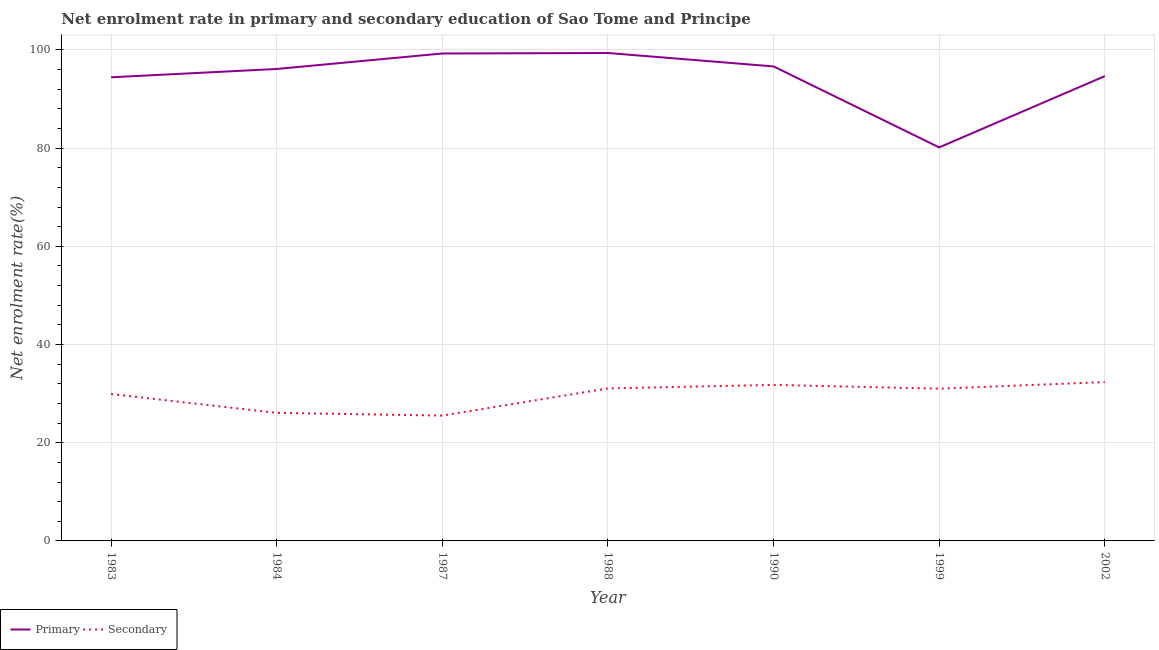What is the enrollment rate in primary education in 1987?
Keep it short and to the point. 99.28. Across all years, what is the maximum enrollment rate in primary education?
Provide a short and direct response. 99.38. Across all years, what is the minimum enrollment rate in primary education?
Your answer should be very brief. 80.15. In which year was the enrollment rate in secondary education maximum?
Ensure brevity in your answer.  2002. In which year was the enrollment rate in secondary education minimum?
Keep it short and to the point. 1987. What is the total enrollment rate in secondary education in the graph?
Make the answer very short. 207.74. What is the difference between the enrollment rate in primary education in 1983 and that in 1990?
Make the answer very short. -2.21. What is the difference between the enrollment rate in primary education in 2002 and the enrollment rate in secondary education in 1988?
Your answer should be very brief. 63.61. What is the average enrollment rate in primary education per year?
Ensure brevity in your answer.  94.38. In the year 2002, what is the difference between the enrollment rate in secondary education and enrollment rate in primary education?
Your answer should be very brief. -62.31. In how many years, is the enrollment rate in primary education greater than 64 %?
Offer a terse response. 7. What is the ratio of the enrollment rate in primary education in 1987 to that in 1988?
Offer a terse response. 1. Is the enrollment rate in secondary education in 1990 less than that in 2002?
Provide a short and direct response. Yes. Is the difference between the enrollment rate in secondary education in 1990 and 2002 greater than the difference between the enrollment rate in primary education in 1990 and 2002?
Ensure brevity in your answer.  No. What is the difference between the highest and the second highest enrollment rate in primary education?
Your response must be concise. 0.1. What is the difference between the highest and the lowest enrollment rate in secondary education?
Offer a terse response. 6.83. Is the sum of the enrollment rate in primary education in 1988 and 1999 greater than the maximum enrollment rate in secondary education across all years?
Offer a very short reply. Yes. Does the enrollment rate in primary education monotonically increase over the years?
Offer a terse response. No. Is the enrollment rate in primary education strictly greater than the enrollment rate in secondary education over the years?
Provide a short and direct response. Yes. Is the enrollment rate in primary education strictly less than the enrollment rate in secondary education over the years?
Make the answer very short. No. Does the graph contain any zero values?
Ensure brevity in your answer.  No. Does the graph contain grids?
Offer a terse response. Yes. How many legend labels are there?
Your response must be concise. 2. What is the title of the graph?
Offer a terse response. Net enrolment rate in primary and secondary education of Sao Tome and Principe. Does "From human activities" appear as one of the legend labels in the graph?
Offer a terse response. No. What is the label or title of the Y-axis?
Your answer should be compact. Net enrolment rate(%). What is the Net enrolment rate(%) in Primary in 1983?
Give a very brief answer. 94.43. What is the Net enrolment rate(%) in Secondary in 1983?
Give a very brief answer. 29.92. What is the Net enrolment rate(%) of Primary in 1984?
Give a very brief answer. 96.13. What is the Net enrolment rate(%) of Secondary in 1984?
Offer a terse response. 26.08. What is the Net enrolment rate(%) of Primary in 1987?
Ensure brevity in your answer.  99.28. What is the Net enrolment rate(%) in Secondary in 1987?
Give a very brief answer. 25.53. What is the Net enrolment rate(%) in Primary in 1988?
Keep it short and to the point. 99.38. What is the Net enrolment rate(%) in Secondary in 1988?
Your response must be concise. 31.06. What is the Net enrolment rate(%) in Primary in 1990?
Ensure brevity in your answer.  96.65. What is the Net enrolment rate(%) of Secondary in 1990?
Your answer should be compact. 31.78. What is the Net enrolment rate(%) in Primary in 1999?
Make the answer very short. 80.15. What is the Net enrolment rate(%) in Secondary in 1999?
Give a very brief answer. 31.01. What is the Net enrolment rate(%) of Primary in 2002?
Offer a terse response. 94.67. What is the Net enrolment rate(%) of Secondary in 2002?
Give a very brief answer. 32.36. Across all years, what is the maximum Net enrolment rate(%) of Primary?
Make the answer very short. 99.38. Across all years, what is the maximum Net enrolment rate(%) of Secondary?
Keep it short and to the point. 32.36. Across all years, what is the minimum Net enrolment rate(%) of Primary?
Provide a short and direct response. 80.15. Across all years, what is the minimum Net enrolment rate(%) in Secondary?
Your answer should be very brief. 25.53. What is the total Net enrolment rate(%) of Primary in the graph?
Give a very brief answer. 660.68. What is the total Net enrolment rate(%) in Secondary in the graph?
Give a very brief answer. 207.74. What is the difference between the Net enrolment rate(%) of Primary in 1983 and that in 1984?
Ensure brevity in your answer.  -1.69. What is the difference between the Net enrolment rate(%) of Secondary in 1983 and that in 1984?
Make the answer very short. 3.85. What is the difference between the Net enrolment rate(%) of Primary in 1983 and that in 1987?
Your answer should be compact. -4.85. What is the difference between the Net enrolment rate(%) of Secondary in 1983 and that in 1987?
Offer a terse response. 4.39. What is the difference between the Net enrolment rate(%) of Primary in 1983 and that in 1988?
Your answer should be compact. -4.95. What is the difference between the Net enrolment rate(%) of Secondary in 1983 and that in 1988?
Offer a terse response. -1.14. What is the difference between the Net enrolment rate(%) of Primary in 1983 and that in 1990?
Your answer should be very brief. -2.21. What is the difference between the Net enrolment rate(%) of Secondary in 1983 and that in 1990?
Give a very brief answer. -1.86. What is the difference between the Net enrolment rate(%) in Primary in 1983 and that in 1999?
Your answer should be very brief. 14.28. What is the difference between the Net enrolment rate(%) of Secondary in 1983 and that in 1999?
Provide a short and direct response. -1.08. What is the difference between the Net enrolment rate(%) of Primary in 1983 and that in 2002?
Provide a short and direct response. -0.24. What is the difference between the Net enrolment rate(%) in Secondary in 1983 and that in 2002?
Provide a short and direct response. -2.43. What is the difference between the Net enrolment rate(%) of Primary in 1984 and that in 1987?
Your answer should be compact. -3.15. What is the difference between the Net enrolment rate(%) of Secondary in 1984 and that in 1987?
Offer a terse response. 0.55. What is the difference between the Net enrolment rate(%) in Primary in 1984 and that in 1988?
Provide a short and direct response. -3.25. What is the difference between the Net enrolment rate(%) of Secondary in 1984 and that in 1988?
Keep it short and to the point. -4.98. What is the difference between the Net enrolment rate(%) in Primary in 1984 and that in 1990?
Offer a very short reply. -0.52. What is the difference between the Net enrolment rate(%) in Secondary in 1984 and that in 1990?
Your response must be concise. -5.7. What is the difference between the Net enrolment rate(%) of Primary in 1984 and that in 1999?
Your response must be concise. 15.97. What is the difference between the Net enrolment rate(%) of Secondary in 1984 and that in 1999?
Offer a terse response. -4.93. What is the difference between the Net enrolment rate(%) of Primary in 1984 and that in 2002?
Provide a short and direct response. 1.46. What is the difference between the Net enrolment rate(%) of Secondary in 1984 and that in 2002?
Your answer should be very brief. -6.28. What is the difference between the Net enrolment rate(%) in Primary in 1987 and that in 1988?
Provide a succinct answer. -0.1. What is the difference between the Net enrolment rate(%) in Secondary in 1987 and that in 1988?
Your response must be concise. -5.53. What is the difference between the Net enrolment rate(%) in Primary in 1987 and that in 1990?
Offer a terse response. 2.63. What is the difference between the Net enrolment rate(%) of Secondary in 1987 and that in 1990?
Your response must be concise. -6.25. What is the difference between the Net enrolment rate(%) in Primary in 1987 and that in 1999?
Provide a succinct answer. 19.13. What is the difference between the Net enrolment rate(%) of Secondary in 1987 and that in 1999?
Give a very brief answer. -5.48. What is the difference between the Net enrolment rate(%) of Primary in 1987 and that in 2002?
Give a very brief answer. 4.61. What is the difference between the Net enrolment rate(%) of Secondary in 1987 and that in 2002?
Offer a very short reply. -6.83. What is the difference between the Net enrolment rate(%) in Primary in 1988 and that in 1990?
Offer a very short reply. 2.73. What is the difference between the Net enrolment rate(%) of Secondary in 1988 and that in 1990?
Give a very brief answer. -0.72. What is the difference between the Net enrolment rate(%) in Primary in 1988 and that in 1999?
Your answer should be compact. 19.22. What is the difference between the Net enrolment rate(%) in Secondary in 1988 and that in 1999?
Keep it short and to the point. 0.05. What is the difference between the Net enrolment rate(%) of Primary in 1988 and that in 2002?
Ensure brevity in your answer.  4.71. What is the difference between the Net enrolment rate(%) of Secondary in 1988 and that in 2002?
Give a very brief answer. -1.3. What is the difference between the Net enrolment rate(%) in Primary in 1990 and that in 1999?
Offer a very short reply. 16.49. What is the difference between the Net enrolment rate(%) of Secondary in 1990 and that in 1999?
Make the answer very short. 0.77. What is the difference between the Net enrolment rate(%) in Primary in 1990 and that in 2002?
Provide a succinct answer. 1.98. What is the difference between the Net enrolment rate(%) of Secondary in 1990 and that in 2002?
Keep it short and to the point. -0.58. What is the difference between the Net enrolment rate(%) in Primary in 1999 and that in 2002?
Offer a terse response. -14.52. What is the difference between the Net enrolment rate(%) of Secondary in 1999 and that in 2002?
Give a very brief answer. -1.35. What is the difference between the Net enrolment rate(%) in Primary in 1983 and the Net enrolment rate(%) in Secondary in 1984?
Your response must be concise. 68.35. What is the difference between the Net enrolment rate(%) in Primary in 1983 and the Net enrolment rate(%) in Secondary in 1987?
Your response must be concise. 68.9. What is the difference between the Net enrolment rate(%) of Primary in 1983 and the Net enrolment rate(%) of Secondary in 1988?
Offer a terse response. 63.37. What is the difference between the Net enrolment rate(%) of Primary in 1983 and the Net enrolment rate(%) of Secondary in 1990?
Your response must be concise. 62.65. What is the difference between the Net enrolment rate(%) of Primary in 1983 and the Net enrolment rate(%) of Secondary in 1999?
Provide a succinct answer. 63.42. What is the difference between the Net enrolment rate(%) in Primary in 1983 and the Net enrolment rate(%) in Secondary in 2002?
Your answer should be compact. 62.08. What is the difference between the Net enrolment rate(%) of Primary in 1984 and the Net enrolment rate(%) of Secondary in 1987?
Your answer should be compact. 70.6. What is the difference between the Net enrolment rate(%) in Primary in 1984 and the Net enrolment rate(%) in Secondary in 1988?
Make the answer very short. 65.06. What is the difference between the Net enrolment rate(%) in Primary in 1984 and the Net enrolment rate(%) in Secondary in 1990?
Offer a terse response. 64.35. What is the difference between the Net enrolment rate(%) of Primary in 1984 and the Net enrolment rate(%) of Secondary in 1999?
Offer a terse response. 65.12. What is the difference between the Net enrolment rate(%) in Primary in 1984 and the Net enrolment rate(%) in Secondary in 2002?
Your answer should be very brief. 63.77. What is the difference between the Net enrolment rate(%) of Primary in 1987 and the Net enrolment rate(%) of Secondary in 1988?
Your response must be concise. 68.22. What is the difference between the Net enrolment rate(%) of Primary in 1987 and the Net enrolment rate(%) of Secondary in 1990?
Make the answer very short. 67.5. What is the difference between the Net enrolment rate(%) of Primary in 1987 and the Net enrolment rate(%) of Secondary in 1999?
Offer a terse response. 68.27. What is the difference between the Net enrolment rate(%) of Primary in 1987 and the Net enrolment rate(%) of Secondary in 2002?
Ensure brevity in your answer.  66.92. What is the difference between the Net enrolment rate(%) of Primary in 1988 and the Net enrolment rate(%) of Secondary in 1990?
Provide a short and direct response. 67.6. What is the difference between the Net enrolment rate(%) of Primary in 1988 and the Net enrolment rate(%) of Secondary in 1999?
Offer a terse response. 68.37. What is the difference between the Net enrolment rate(%) of Primary in 1988 and the Net enrolment rate(%) of Secondary in 2002?
Keep it short and to the point. 67.02. What is the difference between the Net enrolment rate(%) of Primary in 1990 and the Net enrolment rate(%) of Secondary in 1999?
Your response must be concise. 65.64. What is the difference between the Net enrolment rate(%) of Primary in 1990 and the Net enrolment rate(%) of Secondary in 2002?
Provide a succinct answer. 64.29. What is the difference between the Net enrolment rate(%) of Primary in 1999 and the Net enrolment rate(%) of Secondary in 2002?
Give a very brief answer. 47.8. What is the average Net enrolment rate(%) of Primary per year?
Offer a terse response. 94.38. What is the average Net enrolment rate(%) in Secondary per year?
Your response must be concise. 29.68. In the year 1983, what is the difference between the Net enrolment rate(%) of Primary and Net enrolment rate(%) of Secondary?
Provide a succinct answer. 64.51. In the year 1984, what is the difference between the Net enrolment rate(%) of Primary and Net enrolment rate(%) of Secondary?
Your response must be concise. 70.05. In the year 1987, what is the difference between the Net enrolment rate(%) in Primary and Net enrolment rate(%) in Secondary?
Keep it short and to the point. 73.75. In the year 1988, what is the difference between the Net enrolment rate(%) of Primary and Net enrolment rate(%) of Secondary?
Provide a succinct answer. 68.32. In the year 1990, what is the difference between the Net enrolment rate(%) in Primary and Net enrolment rate(%) in Secondary?
Your answer should be very brief. 64.87. In the year 1999, what is the difference between the Net enrolment rate(%) in Primary and Net enrolment rate(%) in Secondary?
Make the answer very short. 49.14. In the year 2002, what is the difference between the Net enrolment rate(%) in Primary and Net enrolment rate(%) in Secondary?
Make the answer very short. 62.31. What is the ratio of the Net enrolment rate(%) in Primary in 1983 to that in 1984?
Your response must be concise. 0.98. What is the ratio of the Net enrolment rate(%) of Secondary in 1983 to that in 1984?
Provide a succinct answer. 1.15. What is the ratio of the Net enrolment rate(%) of Primary in 1983 to that in 1987?
Offer a very short reply. 0.95. What is the ratio of the Net enrolment rate(%) in Secondary in 1983 to that in 1987?
Provide a succinct answer. 1.17. What is the ratio of the Net enrolment rate(%) in Primary in 1983 to that in 1988?
Keep it short and to the point. 0.95. What is the ratio of the Net enrolment rate(%) in Secondary in 1983 to that in 1988?
Make the answer very short. 0.96. What is the ratio of the Net enrolment rate(%) of Primary in 1983 to that in 1990?
Provide a succinct answer. 0.98. What is the ratio of the Net enrolment rate(%) of Secondary in 1983 to that in 1990?
Your answer should be very brief. 0.94. What is the ratio of the Net enrolment rate(%) in Primary in 1983 to that in 1999?
Your answer should be very brief. 1.18. What is the ratio of the Net enrolment rate(%) of Secondary in 1983 to that in 1999?
Make the answer very short. 0.96. What is the ratio of the Net enrolment rate(%) in Secondary in 1983 to that in 2002?
Your response must be concise. 0.92. What is the ratio of the Net enrolment rate(%) in Primary in 1984 to that in 1987?
Offer a very short reply. 0.97. What is the ratio of the Net enrolment rate(%) in Secondary in 1984 to that in 1987?
Ensure brevity in your answer.  1.02. What is the ratio of the Net enrolment rate(%) of Primary in 1984 to that in 1988?
Make the answer very short. 0.97. What is the ratio of the Net enrolment rate(%) of Secondary in 1984 to that in 1988?
Offer a terse response. 0.84. What is the ratio of the Net enrolment rate(%) in Secondary in 1984 to that in 1990?
Give a very brief answer. 0.82. What is the ratio of the Net enrolment rate(%) of Primary in 1984 to that in 1999?
Provide a succinct answer. 1.2. What is the ratio of the Net enrolment rate(%) in Secondary in 1984 to that in 1999?
Give a very brief answer. 0.84. What is the ratio of the Net enrolment rate(%) of Primary in 1984 to that in 2002?
Give a very brief answer. 1.02. What is the ratio of the Net enrolment rate(%) in Secondary in 1984 to that in 2002?
Offer a very short reply. 0.81. What is the ratio of the Net enrolment rate(%) of Primary in 1987 to that in 1988?
Offer a terse response. 1. What is the ratio of the Net enrolment rate(%) of Secondary in 1987 to that in 1988?
Your answer should be compact. 0.82. What is the ratio of the Net enrolment rate(%) in Primary in 1987 to that in 1990?
Keep it short and to the point. 1.03. What is the ratio of the Net enrolment rate(%) of Secondary in 1987 to that in 1990?
Provide a short and direct response. 0.8. What is the ratio of the Net enrolment rate(%) in Primary in 1987 to that in 1999?
Offer a very short reply. 1.24. What is the ratio of the Net enrolment rate(%) of Secondary in 1987 to that in 1999?
Offer a terse response. 0.82. What is the ratio of the Net enrolment rate(%) of Primary in 1987 to that in 2002?
Give a very brief answer. 1.05. What is the ratio of the Net enrolment rate(%) in Secondary in 1987 to that in 2002?
Offer a very short reply. 0.79. What is the ratio of the Net enrolment rate(%) in Primary in 1988 to that in 1990?
Give a very brief answer. 1.03. What is the ratio of the Net enrolment rate(%) in Secondary in 1988 to that in 1990?
Give a very brief answer. 0.98. What is the ratio of the Net enrolment rate(%) of Primary in 1988 to that in 1999?
Offer a terse response. 1.24. What is the ratio of the Net enrolment rate(%) in Secondary in 1988 to that in 1999?
Your answer should be compact. 1. What is the ratio of the Net enrolment rate(%) of Primary in 1988 to that in 2002?
Ensure brevity in your answer.  1.05. What is the ratio of the Net enrolment rate(%) in Secondary in 1988 to that in 2002?
Your answer should be very brief. 0.96. What is the ratio of the Net enrolment rate(%) in Primary in 1990 to that in 1999?
Provide a short and direct response. 1.21. What is the ratio of the Net enrolment rate(%) of Secondary in 1990 to that in 1999?
Your answer should be very brief. 1.02. What is the ratio of the Net enrolment rate(%) in Primary in 1990 to that in 2002?
Offer a terse response. 1.02. What is the ratio of the Net enrolment rate(%) of Secondary in 1990 to that in 2002?
Give a very brief answer. 0.98. What is the ratio of the Net enrolment rate(%) in Primary in 1999 to that in 2002?
Your answer should be very brief. 0.85. What is the ratio of the Net enrolment rate(%) of Secondary in 1999 to that in 2002?
Your answer should be compact. 0.96. What is the difference between the highest and the second highest Net enrolment rate(%) of Primary?
Your answer should be very brief. 0.1. What is the difference between the highest and the second highest Net enrolment rate(%) in Secondary?
Keep it short and to the point. 0.58. What is the difference between the highest and the lowest Net enrolment rate(%) in Primary?
Ensure brevity in your answer.  19.22. What is the difference between the highest and the lowest Net enrolment rate(%) of Secondary?
Ensure brevity in your answer.  6.83. 